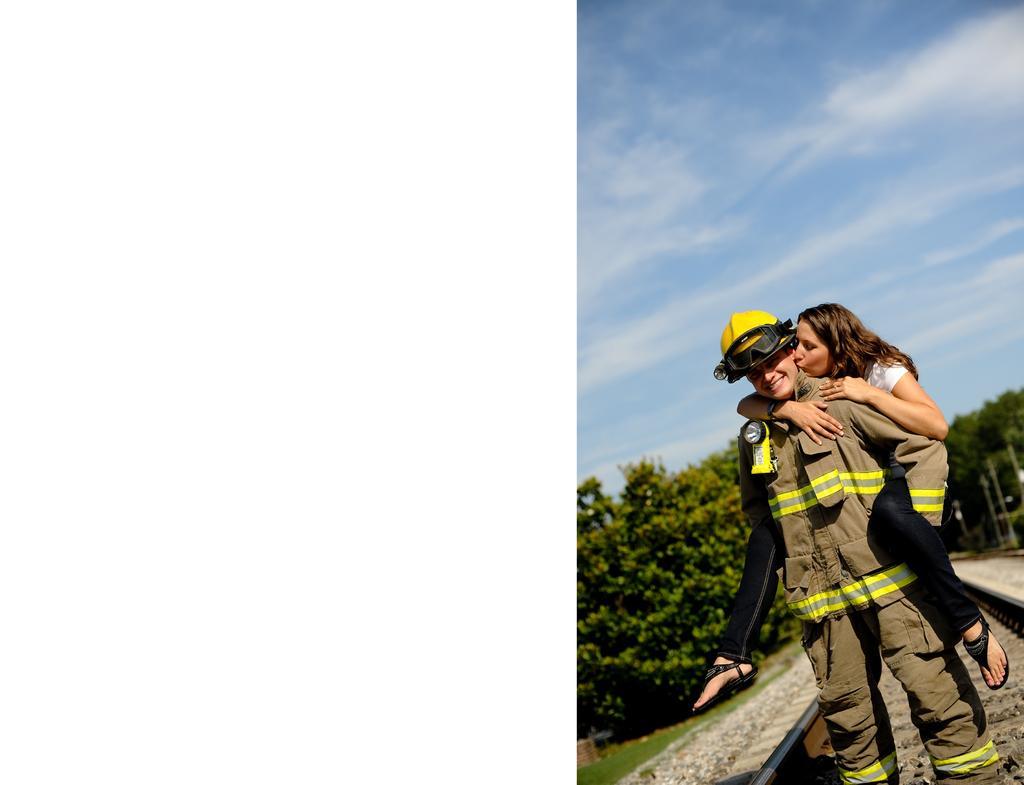How would you summarize this image in a sentence or two? Here we can see a person standing on a railway track and we can see a woman holding the person and with her hands and she is on the person. In the background there are trees,poles and clouds in the sky. 